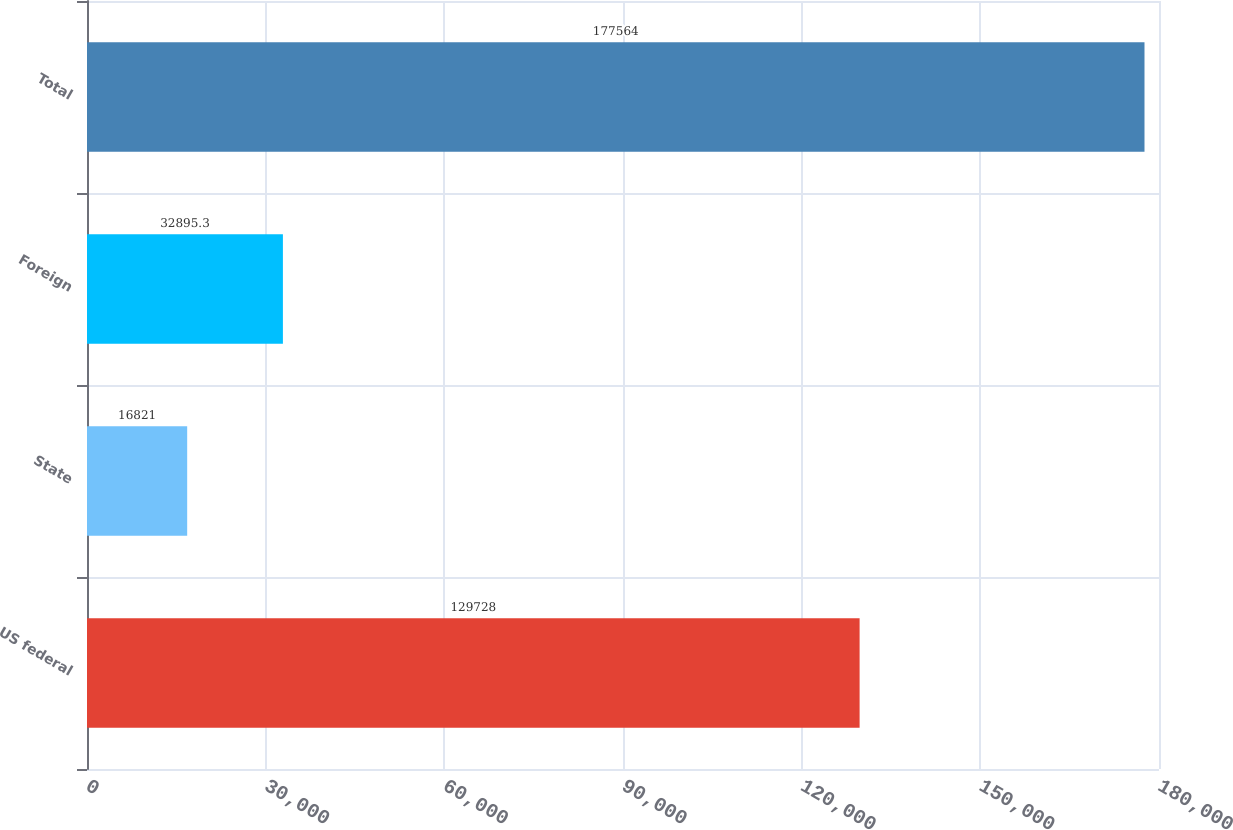<chart> <loc_0><loc_0><loc_500><loc_500><bar_chart><fcel>US federal<fcel>State<fcel>Foreign<fcel>Total<nl><fcel>129728<fcel>16821<fcel>32895.3<fcel>177564<nl></chart> 